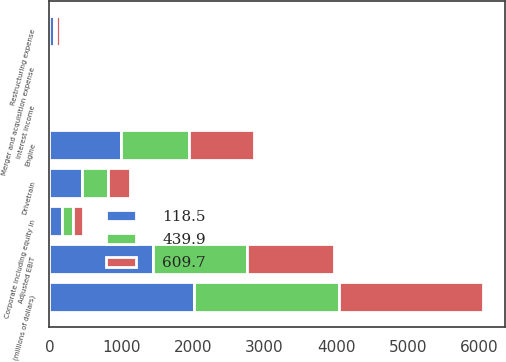Convert chart to OTSL. <chart><loc_0><loc_0><loc_500><loc_500><stacked_bar_chart><ecel><fcel>(millions of dollars)<fcel>Engine<fcel>Drivetrain<fcel>Adjusted EBIT<fcel>Restructuring expense<fcel>Merger and acquisition expense<fcel>Corporate including equity in<fcel>Interest income<nl><fcel>118.5<fcel>2017<fcel>995.7<fcel>449.8<fcel>1445.5<fcel>58.5<fcel>10<fcel>170.3<fcel>5.8<nl><fcel>439.9<fcel>2016<fcel>947.3<fcel>364.5<fcel>1311.8<fcel>26.9<fcel>23.7<fcel>155.3<fcel>6.3<nl><fcel>609.7<fcel>2015<fcel>913.9<fcel>304.6<fcel>1218.5<fcel>65.7<fcel>21.8<fcel>136.4<fcel>7.5<nl></chart> 